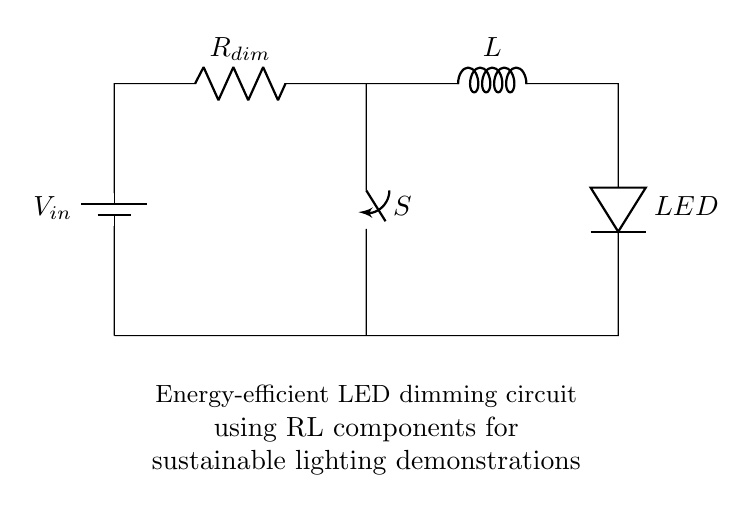What type of switch is used in this circuit? The circuit uses a switch labeled S, which is a mechanical device that can open or close the circuit, allowing for control over the flow of current through the LED.
Answer: switch What is the function of the inductor in this circuit? The inductor is used to store energy in a magnetic field when current flows through it. In this LED dimming circuit, it helps to smooth out the current and prevent sudden changes that can affect LED brightness.
Answer: energy storage What does the resistor R dim do? The resistor labeled R-dim limits the current flowing through the LED, which in turn reduces its brightness. Adjusting this resistor can help achieve energy efficiency in the circuit.
Answer: current limiting What will happen if the switch S is open? If the switch S is open, the circuit is incomplete, which means no current will flow through the components, and the LED will not light up.
Answer: LED off How does the inductor affect the LED's brightness when the switch is closed? When the switch is closed, the inductor allows current to ramp up gradually, which reduces the risk of sudden spikes in current through the LED. This results in more stable and controllable brightness.
Answer: stable brightness Which components are used for energy efficiency in this circuit? The components for energy efficiency include the resistor R, the inductor L, and the LED, as they work together to regulate current and reduce power loss.
Answer: resistor, inductor, LED 